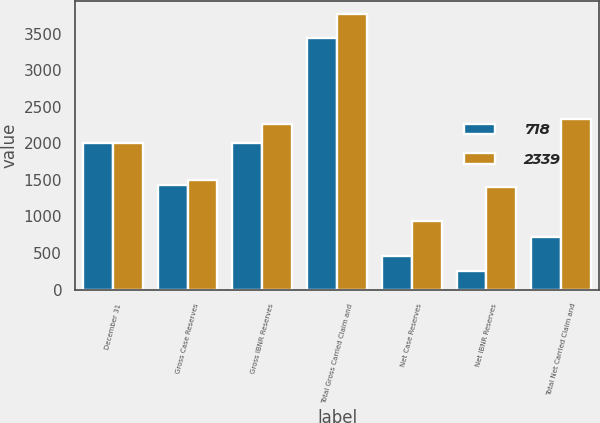Convert chart to OTSL. <chart><loc_0><loc_0><loc_500><loc_500><stacked_bar_chart><ecel><fcel>December 31<fcel>Gross Case Reserves<fcel>Gross IBNR Reserves<fcel>Total Gross Carried Claim and<fcel>Net Case Reserves<fcel>Net IBNR Reserves<fcel>Total Net Carried Claim and<nl><fcel>718<fcel>2010<fcel>1430<fcel>2012<fcel>3442<fcel>461<fcel>257<fcel>718<nl><fcel>2339<fcel>2009<fcel>1503<fcel>2265<fcel>3768<fcel>935<fcel>1404<fcel>2339<nl></chart> 